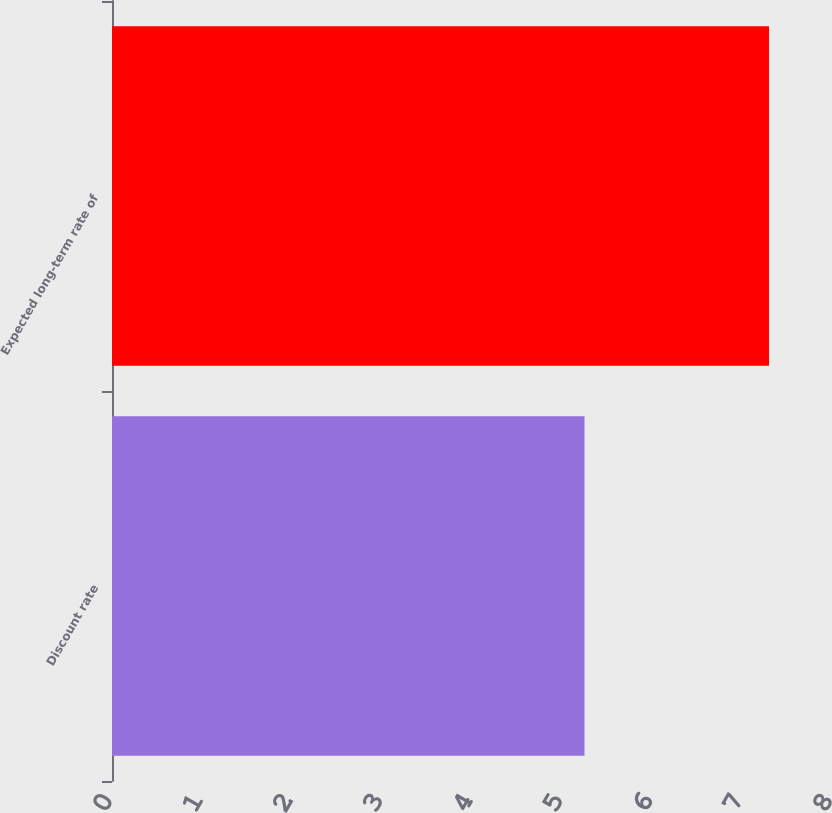Convert chart. <chart><loc_0><loc_0><loc_500><loc_500><bar_chart><fcel>Discount rate<fcel>Expected long-term rate of<nl><fcel>5.25<fcel>7.3<nl></chart> 